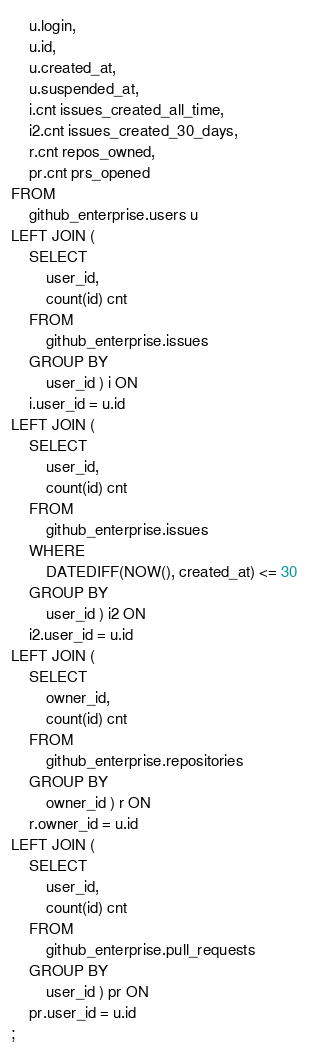<code> <loc_0><loc_0><loc_500><loc_500><_SQL_>	u.login,
	u.id,
	u.created_at,
	u.suspended_at,
	i.cnt issues_created_all_time,
	i2.cnt issues_created_30_days,
	r.cnt repos_owned,
	pr.cnt prs_opened
FROM
	github_enterprise.users u
LEFT JOIN (
	SELECT
		user_id,
		count(id) cnt
	FROM
		github_enterprise.issues
	GROUP BY
		user_id ) i ON
	i.user_id = u.id
LEFT JOIN (
	SELECT
		user_id,
		count(id) cnt
	FROM
		github_enterprise.issues
	WHERE
		DATEDIFF(NOW(), created_at) <= 30
	GROUP BY
		user_id ) i2 ON
	i2.user_id = u.id
LEFT JOIN (
	SELECT
		owner_id,
		count(id) cnt
	FROM
		github_enterprise.repositories
	GROUP BY
		owner_id ) r ON
	r.owner_id = u.id
LEFT JOIN (
	SELECT
		user_id,
		count(id) cnt
	FROM
		github_enterprise.pull_requests
	GROUP BY
		user_id ) pr ON
	pr.user_id = u.id
;
</code> 